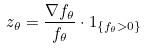<formula> <loc_0><loc_0><loc_500><loc_500>z _ { \theta } = \frac { \nabla f _ { \theta } } { f _ { \theta } } \cdot 1 _ { \{ f _ { \theta } > 0 \} }</formula> 